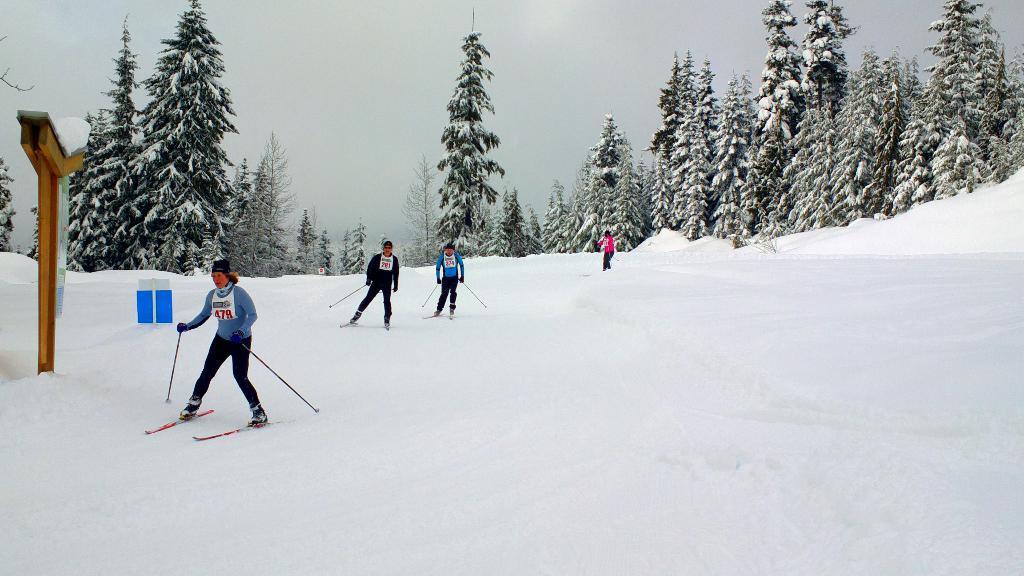Describe this image in one or two sentences. In this picture I can see trees and few people skiing and I can see snow on the ground and a wooden pole and I can see a cloudy sky. 